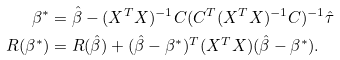Convert formula to latex. <formula><loc_0><loc_0><loc_500><loc_500>\beta ^ { * } & = \hat { \beta } - ( X ^ { T } X ) ^ { - 1 } C ( C ^ { T } ( X ^ { T } X ) ^ { - 1 } C ) ^ { - 1 } \hat { \tau } \\ R ( \beta ^ { * } ) & = R ( \hat { \beta } ) + ( \hat { \beta } - \beta ^ { * } ) ^ { T } ( X ^ { T } X ) ( \hat { \beta } - \beta ^ { * } ) .</formula> 